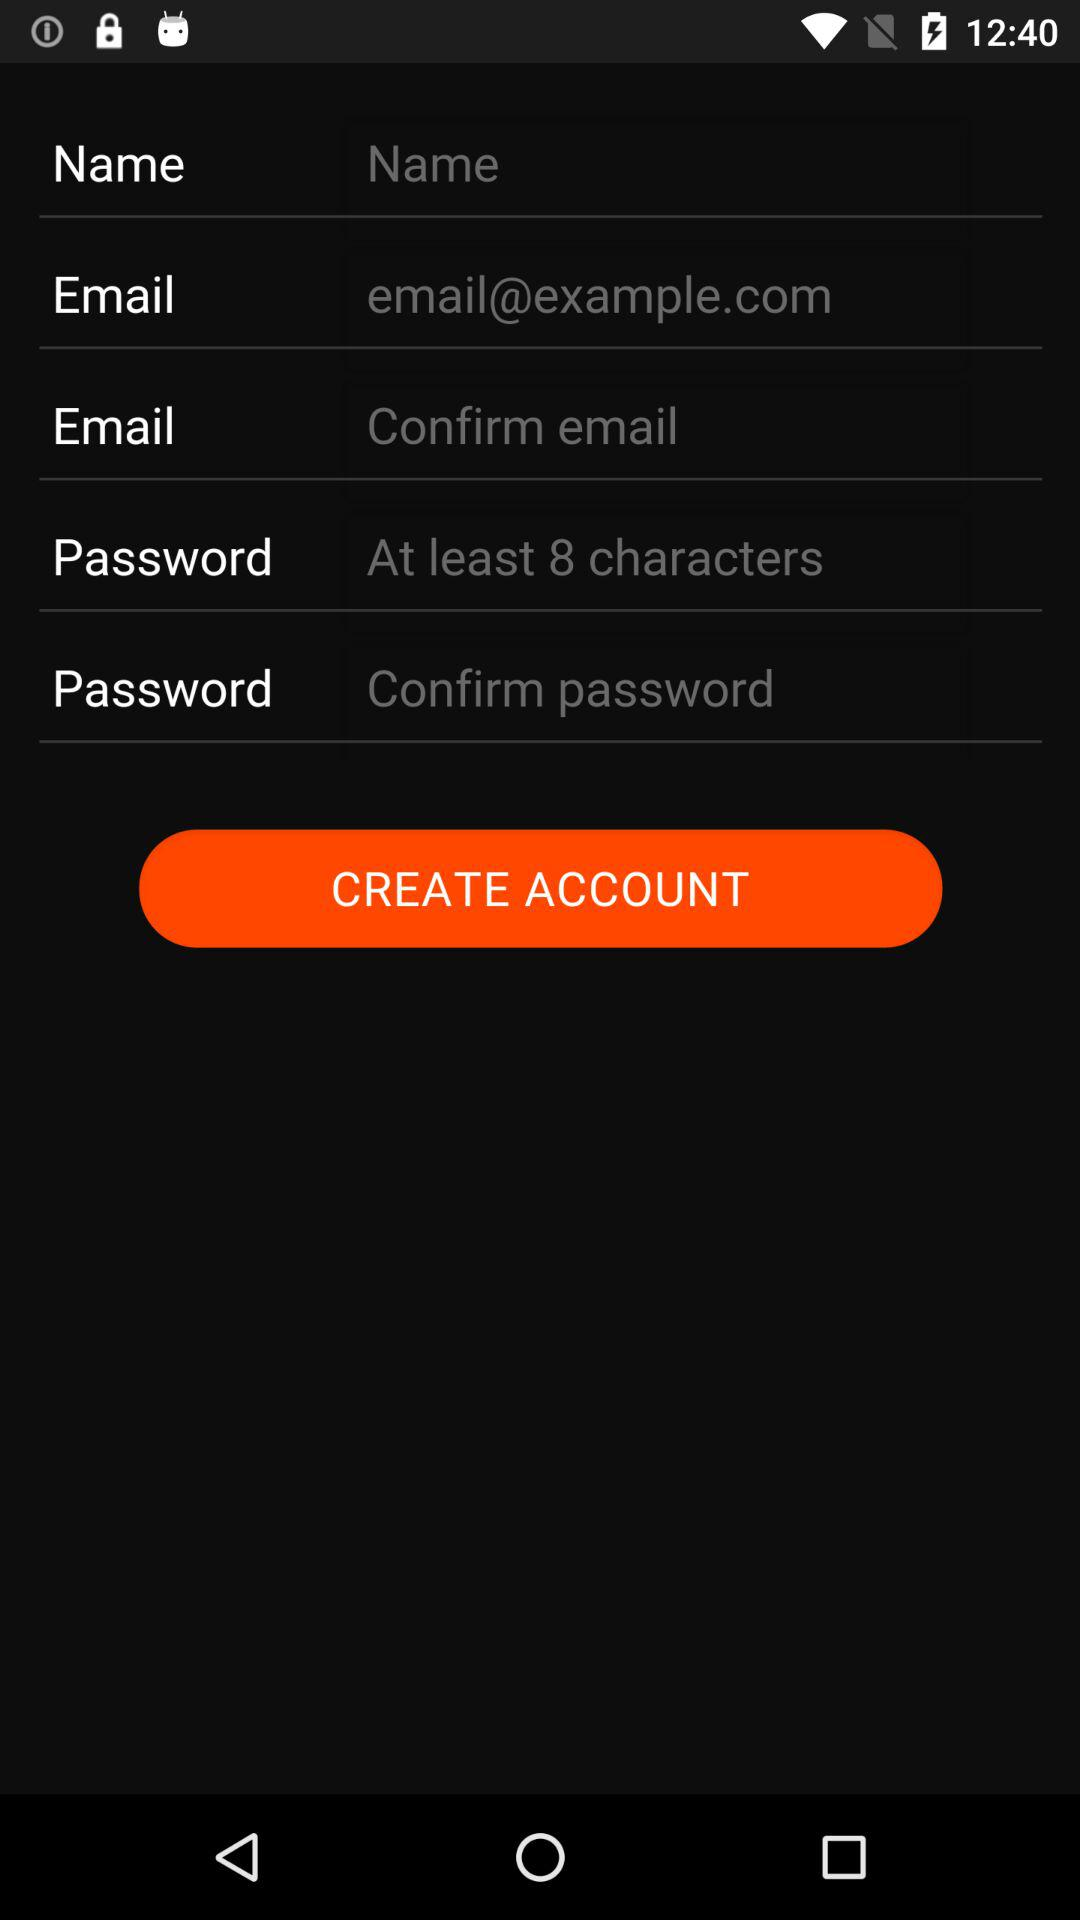What is the user's name?
When the provided information is insufficient, respond with <no answer>. <no answer> 